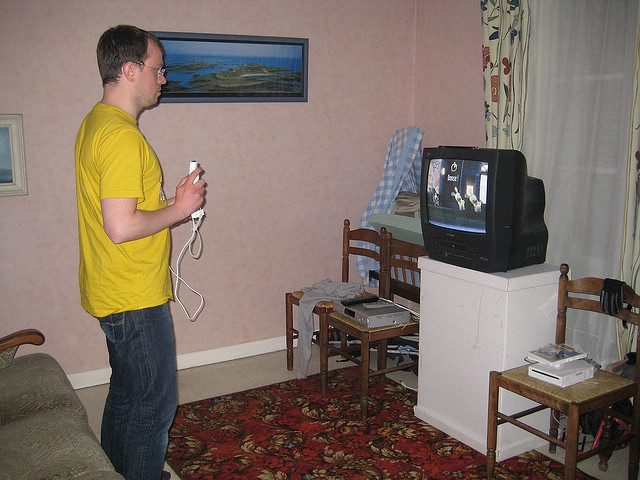Describe the objects in this image and their specific colors. I can see people in gray, black, gold, olive, and salmon tones, chair in gray, black, maroon, and darkgray tones, tv in gray, black, blue, and lightgray tones, couch in gray, black, and maroon tones, and chair in gray, black, and maroon tones in this image. 